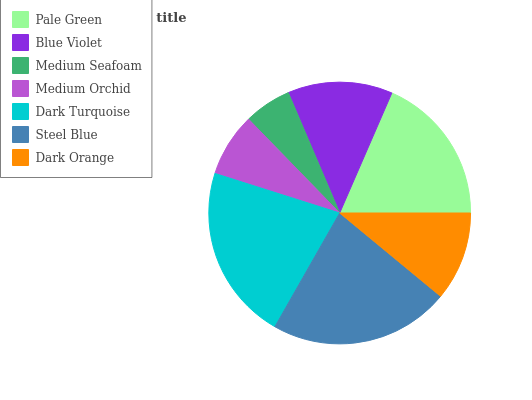Is Medium Seafoam the minimum?
Answer yes or no. Yes. Is Steel Blue the maximum?
Answer yes or no. Yes. Is Blue Violet the minimum?
Answer yes or no. No. Is Blue Violet the maximum?
Answer yes or no. No. Is Pale Green greater than Blue Violet?
Answer yes or no. Yes. Is Blue Violet less than Pale Green?
Answer yes or no. Yes. Is Blue Violet greater than Pale Green?
Answer yes or no. No. Is Pale Green less than Blue Violet?
Answer yes or no. No. Is Blue Violet the high median?
Answer yes or no. Yes. Is Blue Violet the low median?
Answer yes or no. Yes. Is Steel Blue the high median?
Answer yes or no. No. Is Dark Turquoise the low median?
Answer yes or no. No. 